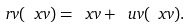Convert formula to latex. <formula><loc_0><loc_0><loc_500><loc_500>\ r v ( \ x v ) = \ x v + \ u v ( \ x v ) .</formula> 